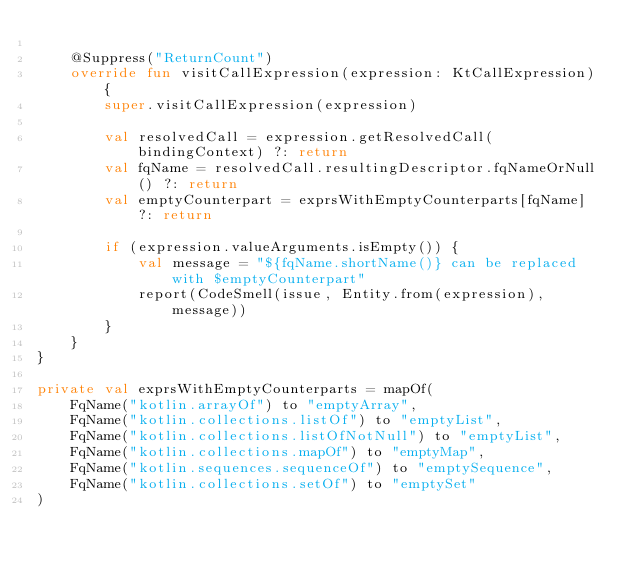<code> <loc_0><loc_0><loc_500><loc_500><_Kotlin_>
    @Suppress("ReturnCount")
    override fun visitCallExpression(expression: KtCallExpression) {
        super.visitCallExpression(expression)

        val resolvedCall = expression.getResolvedCall(bindingContext) ?: return
        val fqName = resolvedCall.resultingDescriptor.fqNameOrNull() ?: return
        val emptyCounterpart = exprsWithEmptyCounterparts[fqName] ?: return

        if (expression.valueArguments.isEmpty()) {
            val message = "${fqName.shortName()} can be replaced with $emptyCounterpart"
            report(CodeSmell(issue, Entity.from(expression), message))
        }
    }
}

private val exprsWithEmptyCounterparts = mapOf(
    FqName("kotlin.arrayOf") to "emptyArray",
    FqName("kotlin.collections.listOf") to "emptyList",
    FqName("kotlin.collections.listOfNotNull") to "emptyList",
    FqName("kotlin.collections.mapOf") to "emptyMap",
    FqName("kotlin.sequences.sequenceOf") to "emptySequence",
    FqName("kotlin.collections.setOf") to "emptySet"
)
</code> 